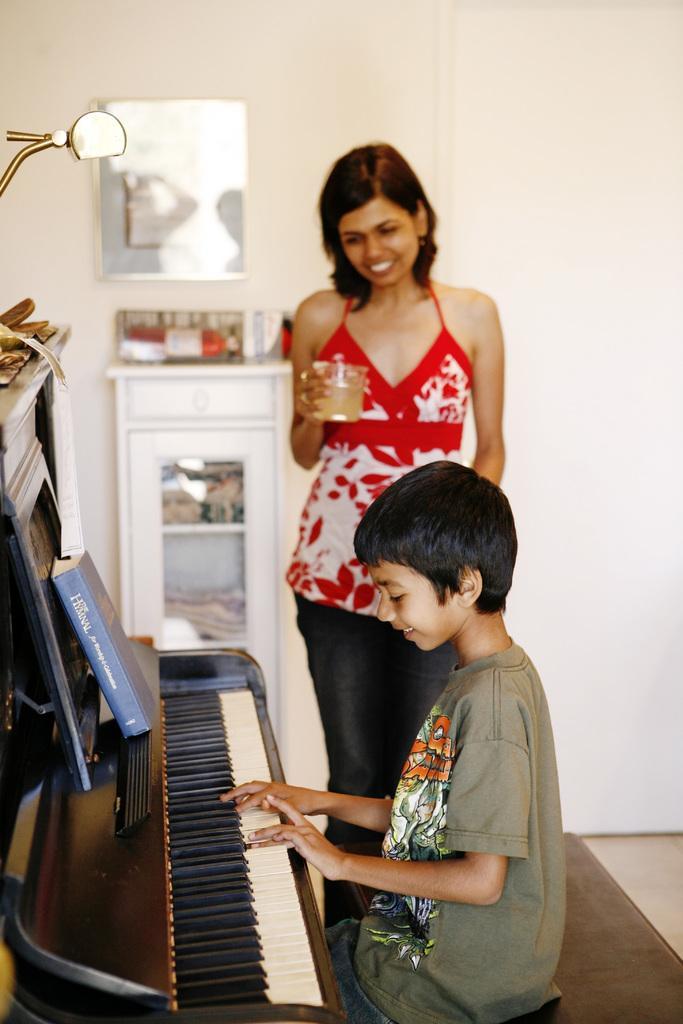How would you summarize this image in a sentence or two? This is the boy sitting on the bench and playing piano. I can see a book which is blue in color is placed above the piano. Here is the woman standing and holding the glass. This looks like a frame attached to the wall. I think this is a rack with few objects placed on it. At the left corner of the image I can see few things placed on the piano table. 